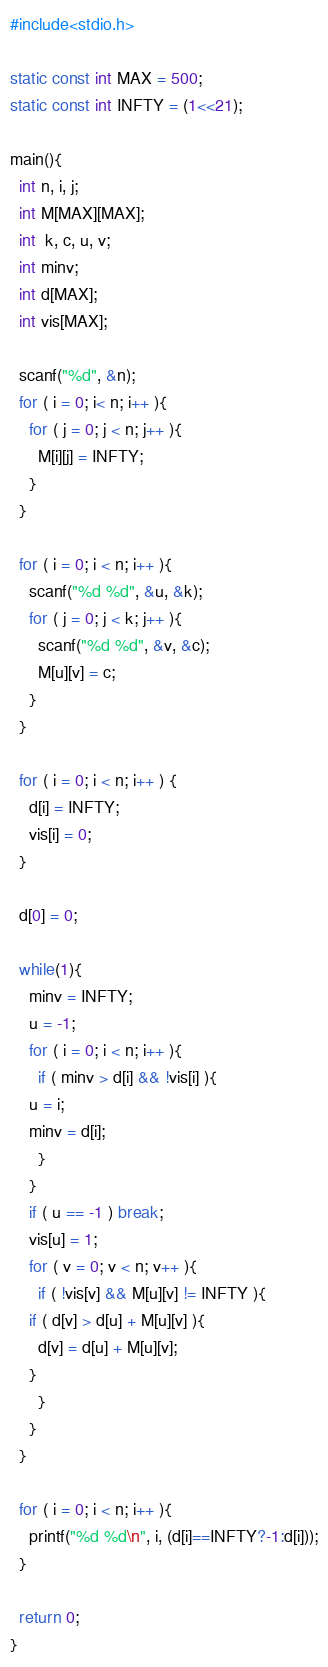<code> <loc_0><loc_0><loc_500><loc_500><_C_>#include<stdio.h>

static const int MAX = 500;
static const int INFTY = (1<<21);

main(){
  int n, i, j;
  int M[MAX][MAX];
  int  k, c, u, v;
  int minv;
  int d[MAX];
  int vis[MAX];

  scanf("%d", &n);
  for ( i = 0; i< n; i++ ){
    for ( j = 0; j < n; j++ ){
      M[i][j] = INFTY;
    }
  }

  for ( i = 0; i < n; i++ ){
    scanf("%d %d", &u, &k);
    for ( j = 0; j < k; j++ ){
      scanf("%d %d", &v, &c);
      M[u][v] = c;
    }
  }

  for ( i = 0; i < n; i++ ) {
    d[i] = INFTY;
    vis[i] = 0;
  }

  d[0] = 0;

  while(1){
    minv = INFTY;
    u = -1;
    for ( i = 0; i < n; i++ ){
      if ( minv > d[i] && !vis[i] ){
	u = i;
	minv = d[i];
      }
    }
    if ( u == -1 ) break;
    vis[u] = 1;
    for ( v = 0; v < n; v++ ){
      if ( !vis[v] && M[u][v] != INFTY ){
	if ( d[v] > d[u] + M[u][v] ){
	  d[v] = d[u] + M[u][v];
	}
      }
    }
  }

  for ( i = 0; i < n; i++ ){
    printf("%d %d\n", i, (d[i]==INFTY?-1:d[i]));
  }

  return 0;
}

</code> 